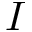<formula> <loc_0><loc_0><loc_500><loc_500>I</formula> 